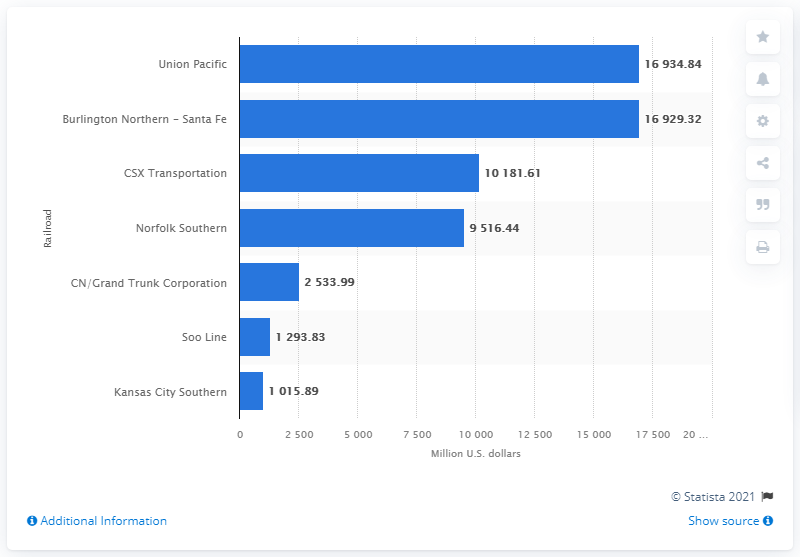Give some essential details in this illustration. In 2010, the operating revenue of Kansas City Southern was 1015.89 dollars. 